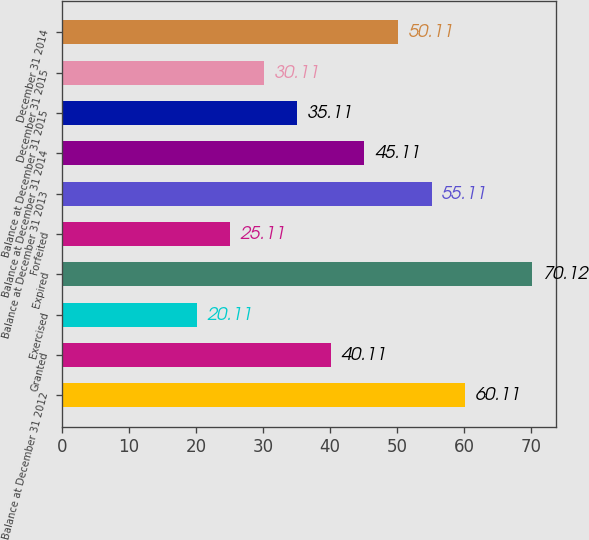<chart> <loc_0><loc_0><loc_500><loc_500><bar_chart><fcel>Balance at December 31 2012<fcel>Granted<fcel>Exercised<fcel>Expired<fcel>Forfeited<fcel>Balance at December 31 2013<fcel>Balance at December 31 2014<fcel>Balance at December 31 2015<fcel>December 31 2015<fcel>December 31 2014<nl><fcel>60.11<fcel>40.11<fcel>20.11<fcel>70.12<fcel>25.11<fcel>55.11<fcel>45.11<fcel>35.11<fcel>30.11<fcel>50.11<nl></chart> 